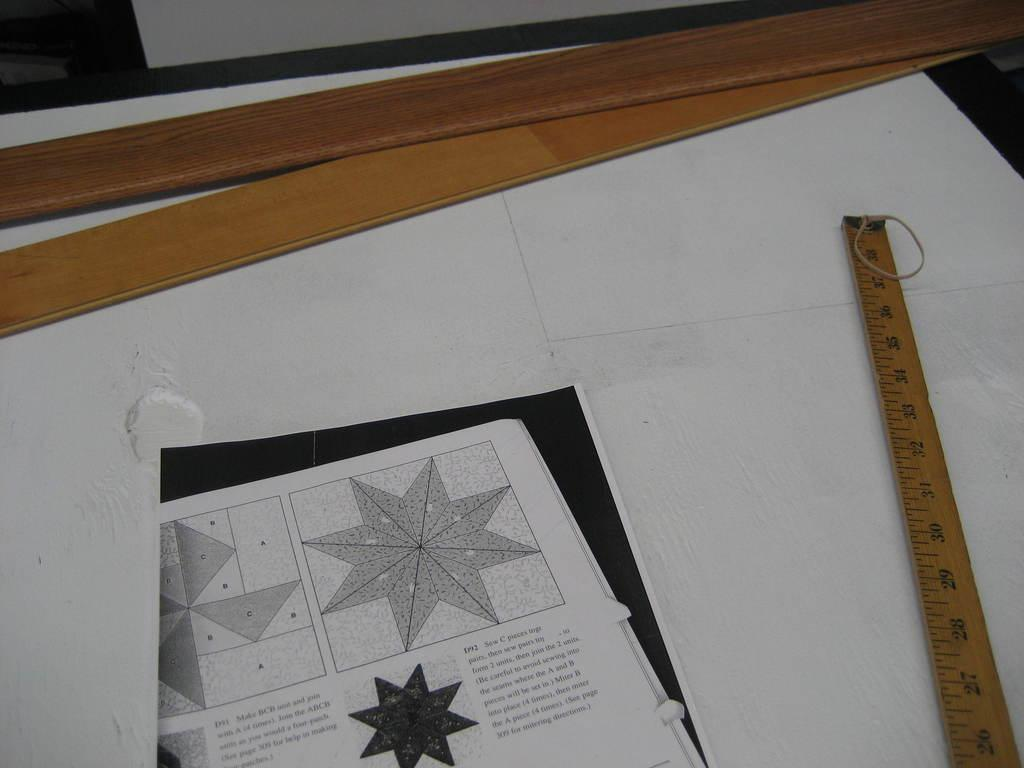<image>
Provide a brief description of the given image. A yardstick sits next to a page of instructions with pieces labeled A, B and C. 